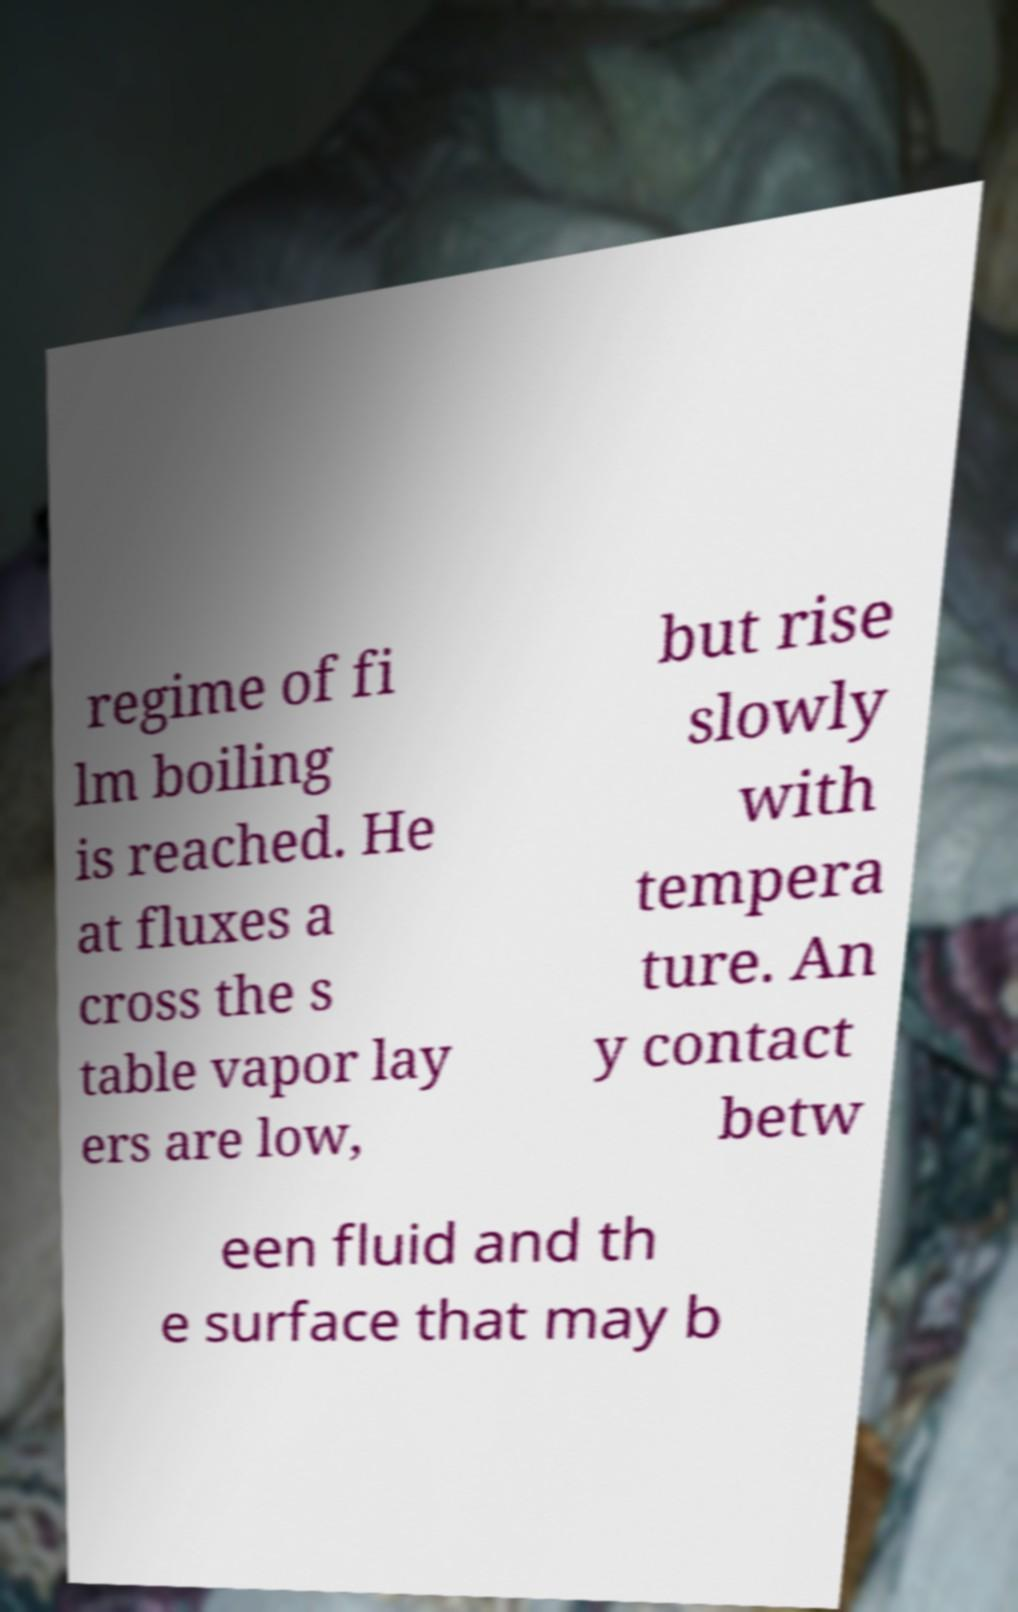Please identify and transcribe the text found in this image. regime of fi lm boiling is reached. He at fluxes a cross the s table vapor lay ers are low, but rise slowly with tempera ture. An y contact betw een fluid and th e surface that may b 